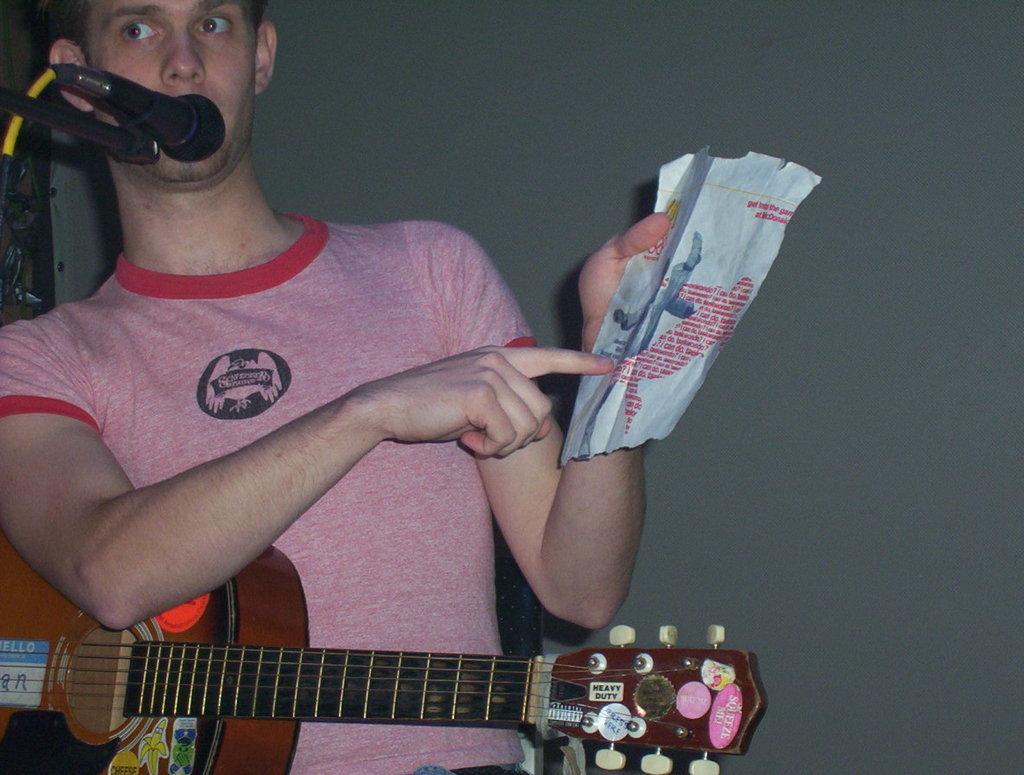In one or two sentences, can you explain what this image depicts? In this picture we can see man holding guitar and paper with his hand and talking on mic and in background we can see wall. 